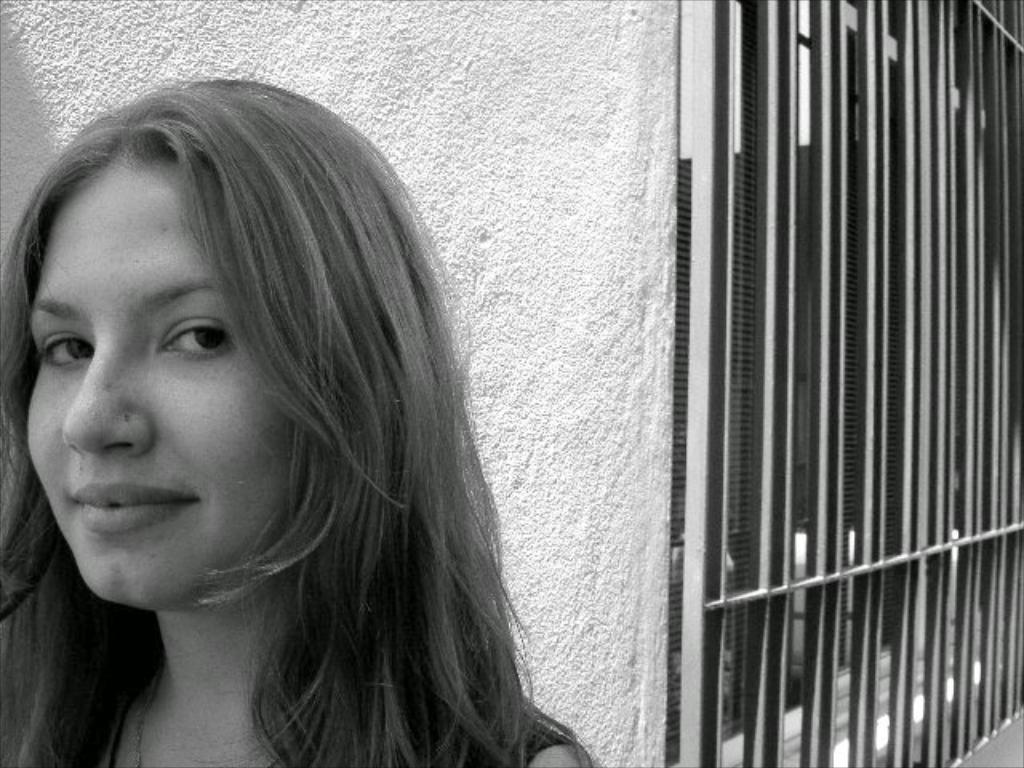Who is the main subject in the image? There is a girl in the image. Can you describe the girl's appearance? The girl has long hair. What is the girl doing in the image? The girl is looking forward and smiling. What type of beetle can be seen crawling on the girl's shoulder in the image? There is no beetle present on the girl's shoulder in the image. What trade is the girl involved in, as depicted in the image? The image does not depict the girl being involved in any trade. 